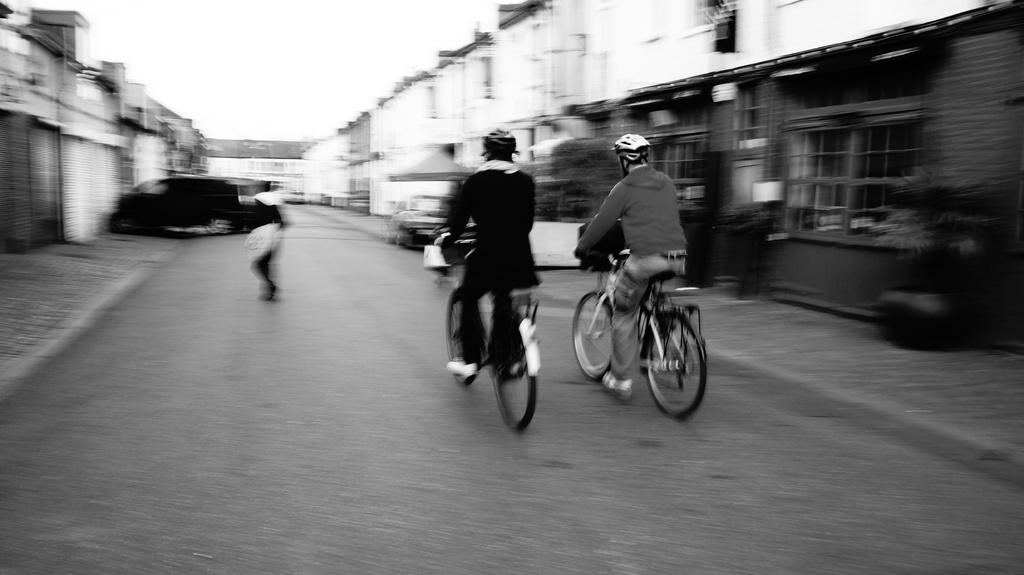What are the two people in the image doing? The two people in the image are riding bicycles. Can you describe the background of the image? The background of the image is blurry. What type of range can be seen in the image? There is no range present in the image. 